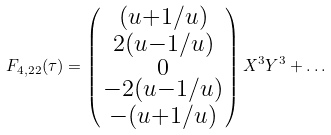Convert formula to latex. <formula><loc_0><loc_0><loc_500><loc_500>F _ { 4 , 2 2 } ( \tau ) = \left ( \begin{smallmatrix} ( u + 1 / u ) \\ 2 ( u - 1 / u ) \\ 0 \\ - 2 ( u - 1 / u ) \\ - ( u + 1 / u ) \end{smallmatrix} \right ) X ^ { 3 } Y ^ { 3 } + \dots</formula> 